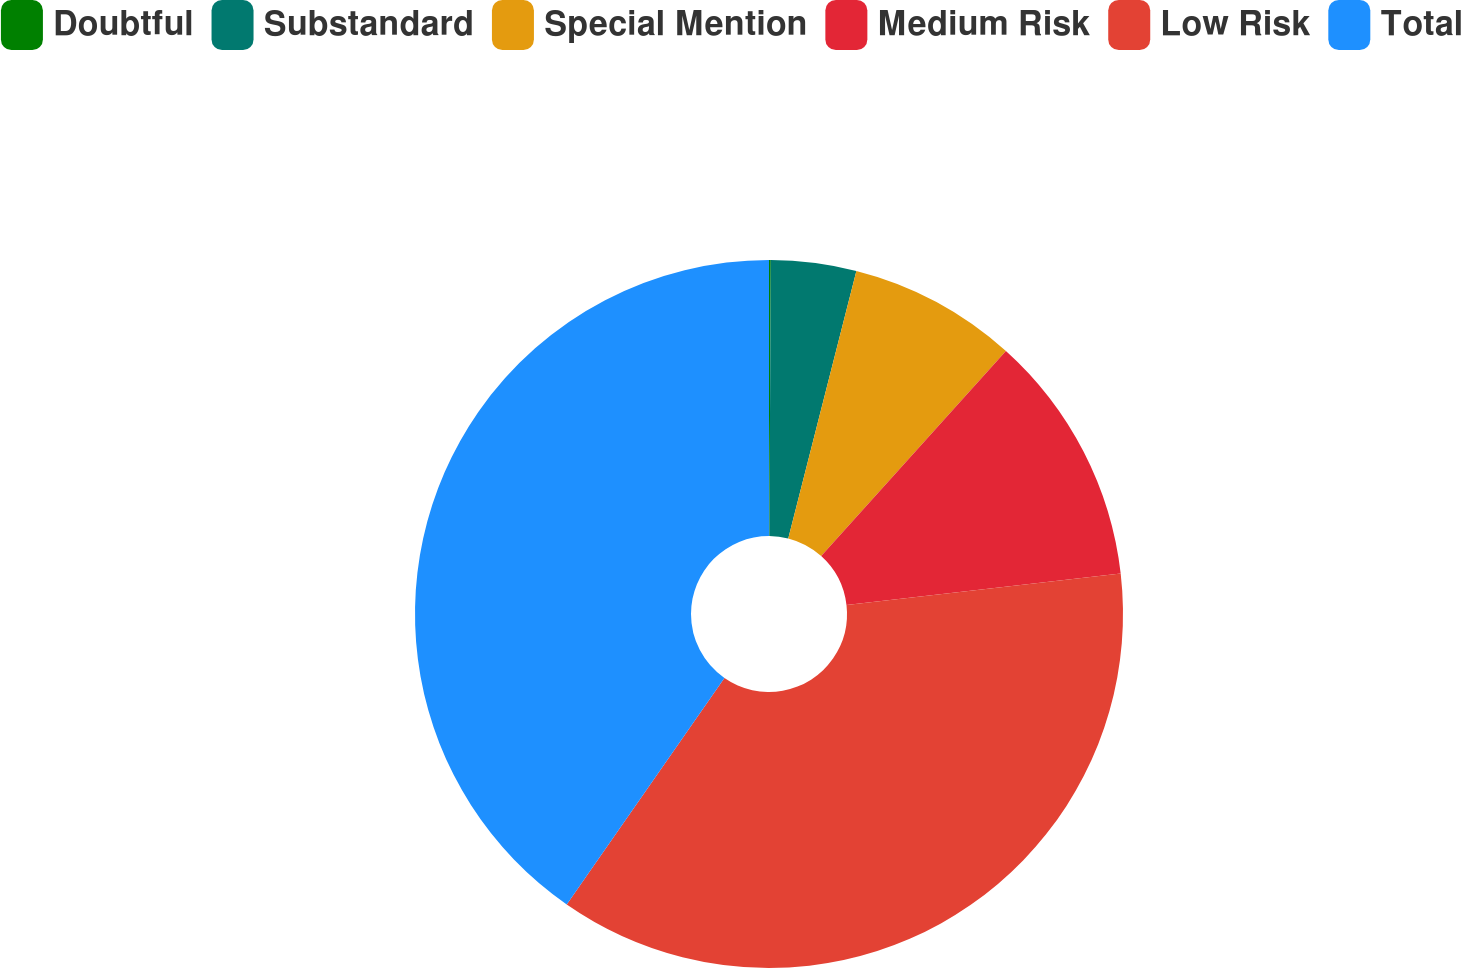Convert chart. <chart><loc_0><loc_0><loc_500><loc_500><pie_chart><fcel>Doubtful<fcel>Substandard<fcel>Special Mention<fcel>Medium Risk<fcel>Low Risk<fcel>Total<nl><fcel>0.08%<fcel>3.89%<fcel>7.7%<fcel>11.51%<fcel>36.5%<fcel>40.32%<nl></chart> 